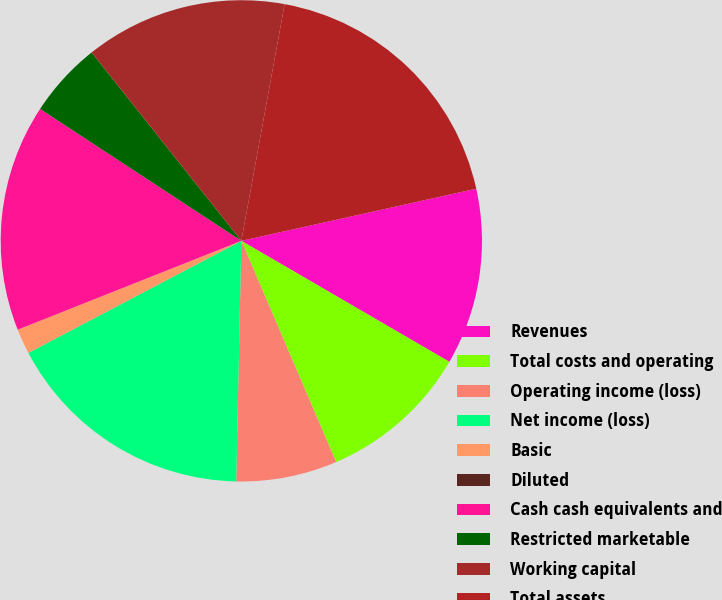Convert chart to OTSL. <chart><loc_0><loc_0><loc_500><loc_500><pie_chart><fcel>Revenues<fcel>Total costs and operating<fcel>Operating income (loss)<fcel>Net income (loss)<fcel>Basic<fcel>Diluted<fcel>Cash cash equivalents and<fcel>Restricted marketable<fcel>Working capital<fcel>Total assets<nl><fcel>11.86%<fcel>10.17%<fcel>6.78%<fcel>16.95%<fcel>1.69%<fcel>0.0%<fcel>15.25%<fcel>5.08%<fcel>13.56%<fcel>18.64%<nl></chart> 